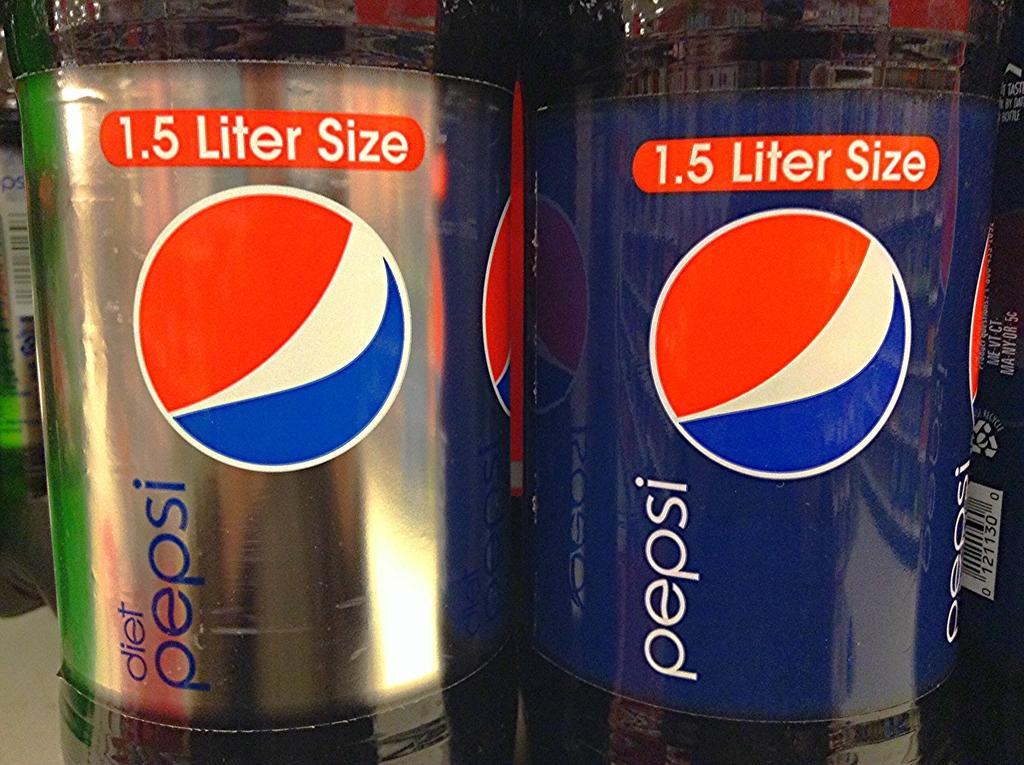<image>
Write a terse but informative summary of the picture. A diet Pepsi and regular Pepsi sit next to each other on a shelf 